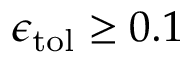Convert formula to latex. <formula><loc_0><loc_0><loc_500><loc_500>\epsilon _ { t o l } \geq 0 . 1 \</formula> 